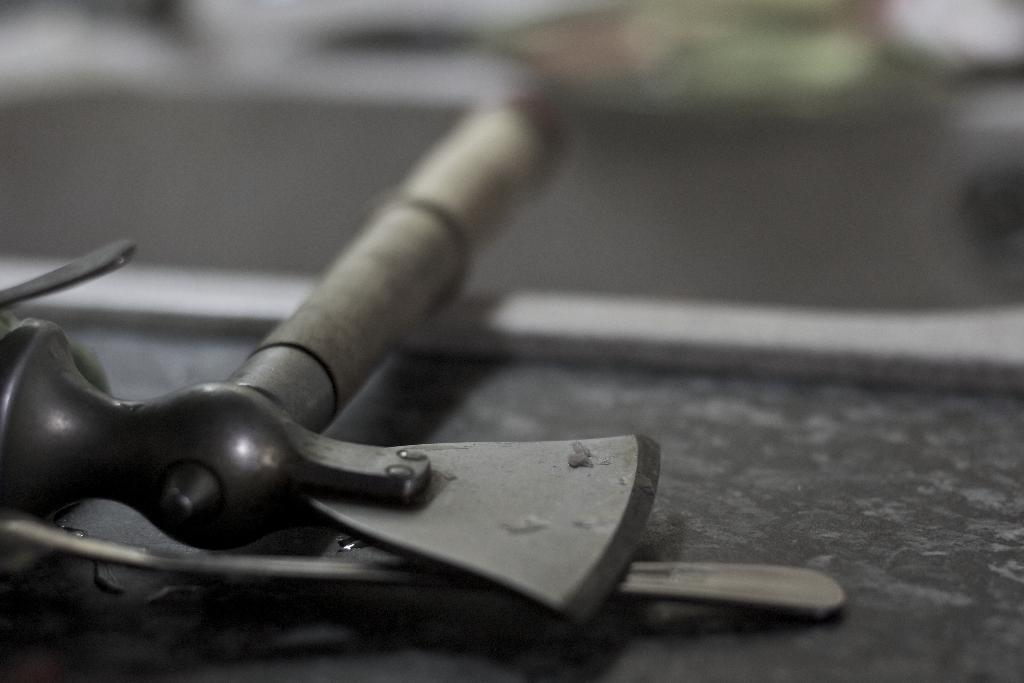What object can be seen in the image? There is an axe in the image. What is the color of the axe? The axe is grey in color. What is the axe resting on? The axe is on a grey surface. How would you describe the background of the image? The background of the image is blurred. What type of winter sport is being played in the image? There is no winter sport or any indication of winter in the image; it features an axe on a grey surface with a blurred background. 